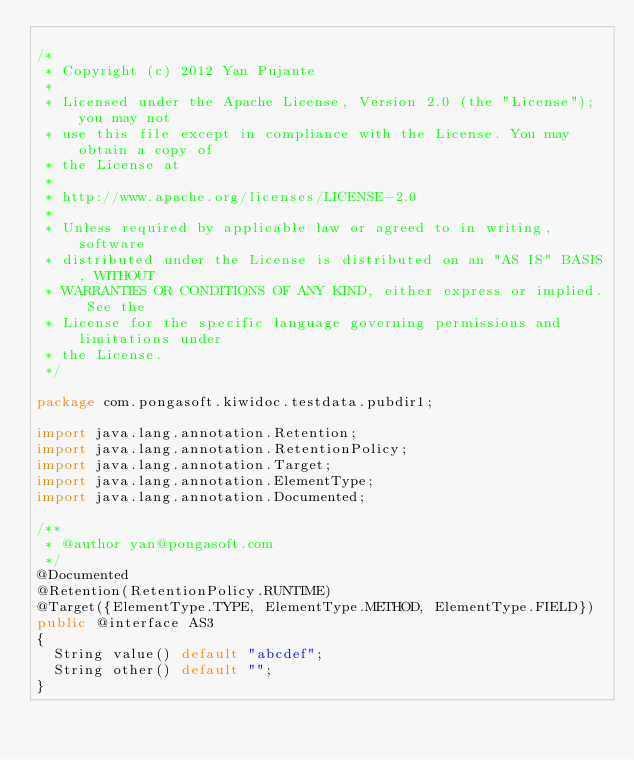Convert code to text. <code><loc_0><loc_0><loc_500><loc_500><_Java_>
/*
 * Copyright (c) 2012 Yan Pujante
 *
 * Licensed under the Apache License, Version 2.0 (the "License"); you may not
 * use this file except in compliance with the License. You may obtain a copy of
 * the License at
 *
 * http://www.apache.org/licenses/LICENSE-2.0
 *
 * Unless required by applicable law or agreed to in writing, software
 * distributed under the License is distributed on an "AS IS" BASIS, WITHOUT
 * WARRANTIES OR CONDITIONS OF ANY KIND, either express or implied. See the
 * License for the specific language governing permissions and limitations under
 * the License.
 */

package com.pongasoft.kiwidoc.testdata.pubdir1;

import java.lang.annotation.Retention;
import java.lang.annotation.RetentionPolicy;
import java.lang.annotation.Target;
import java.lang.annotation.ElementType;
import java.lang.annotation.Documented;

/**
 * @author yan@pongasoft.com
 */
@Documented
@Retention(RetentionPolicy.RUNTIME)
@Target({ElementType.TYPE, ElementType.METHOD, ElementType.FIELD})
public @interface AS3
{
  String value() default "abcdef";
  String other() default "";
}</code> 